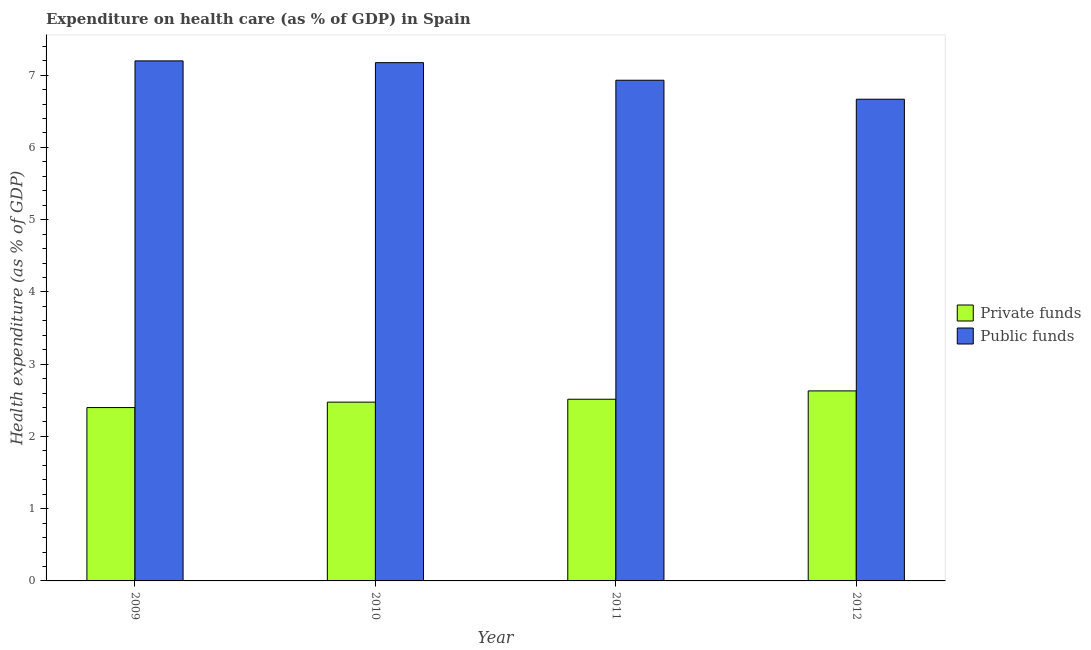Are the number of bars per tick equal to the number of legend labels?
Ensure brevity in your answer.  Yes. What is the label of the 2nd group of bars from the left?
Your answer should be very brief. 2010. In how many cases, is the number of bars for a given year not equal to the number of legend labels?
Your answer should be very brief. 0. What is the amount of private funds spent in healthcare in 2009?
Make the answer very short. 2.4. Across all years, what is the maximum amount of public funds spent in healthcare?
Your answer should be compact. 7.2. Across all years, what is the minimum amount of public funds spent in healthcare?
Your answer should be compact. 6.67. In which year was the amount of private funds spent in healthcare minimum?
Give a very brief answer. 2009. What is the total amount of public funds spent in healthcare in the graph?
Offer a very short reply. 27.97. What is the difference between the amount of public funds spent in healthcare in 2010 and that in 2011?
Offer a terse response. 0.24. What is the difference between the amount of public funds spent in healthcare in 2010 and the amount of private funds spent in healthcare in 2009?
Offer a terse response. -0.02. What is the average amount of public funds spent in healthcare per year?
Offer a very short reply. 6.99. In the year 2011, what is the difference between the amount of public funds spent in healthcare and amount of private funds spent in healthcare?
Provide a succinct answer. 0. What is the ratio of the amount of private funds spent in healthcare in 2009 to that in 2011?
Offer a very short reply. 0.95. Is the difference between the amount of private funds spent in healthcare in 2011 and 2012 greater than the difference between the amount of public funds spent in healthcare in 2011 and 2012?
Give a very brief answer. No. What is the difference between the highest and the second highest amount of public funds spent in healthcare?
Provide a short and direct response. 0.02. What is the difference between the highest and the lowest amount of public funds spent in healthcare?
Your response must be concise. 0.53. What does the 2nd bar from the left in 2011 represents?
Offer a very short reply. Public funds. What does the 2nd bar from the right in 2012 represents?
Offer a very short reply. Private funds. Are all the bars in the graph horizontal?
Offer a terse response. No. Does the graph contain grids?
Offer a terse response. No. Where does the legend appear in the graph?
Your response must be concise. Center right. How are the legend labels stacked?
Offer a very short reply. Vertical. What is the title of the graph?
Your answer should be compact. Expenditure on health care (as % of GDP) in Spain. Does "IMF concessional" appear as one of the legend labels in the graph?
Make the answer very short. No. What is the label or title of the X-axis?
Your answer should be very brief. Year. What is the label or title of the Y-axis?
Provide a succinct answer. Health expenditure (as % of GDP). What is the Health expenditure (as % of GDP) of Private funds in 2009?
Keep it short and to the point. 2.4. What is the Health expenditure (as % of GDP) of Public funds in 2009?
Provide a succinct answer. 7.2. What is the Health expenditure (as % of GDP) of Private funds in 2010?
Offer a very short reply. 2.47. What is the Health expenditure (as % of GDP) in Public funds in 2010?
Your answer should be very brief. 7.17. What is the Health expenditure (as % of GDP) in Private funds in 2011?
Keep it short and to the point. 2.51. What is the Health expenditure (as % of GDP) of Public funds in 2011?
Make the answer very short. 6.93. What is the Health expenditure (as % of GDP) of Private funds in 2012?
Give a very brief answer. 2.63. What is the Health expenditure (as % of GDP) of Public funds in 2012?
Provide a succinct answer. 6.67. Across all years, what is the maximum Health expenditure (as % of GDP) in Private funds?
Your answer should be compact. 2.63. Across all years, what is the maximum Health expenditure (as % of GDP) in Public funds?
Offer a very short reply. 7.2. Across all years, what is the minimum Health expenditure (as % of GDP) in Private funds?
Your response must be concise. 2.4. Across all years, what is the minimum Health expenditure (as % of GDP) of Public funds?
Ensure brevity in your answer.  6.67. What is the total Health expenditure (as % of GDP) of Private funds in the graph?
Your response must be concise. 10.02. What is the total Health expenditure (as % of GDP) of Public funds in the graph?
Your answer should be compact. 27.97. What is the difference between the Health expenditure (as % of GDP) in Private funds in 2009 and that in 2010?
Provide a short and direct response. -0.08. What is the difference between the Health expenditure (as % of GDP) in Public funds in 2009 and that in 2010?
Offer a terse response. 0.02. What is the difference between the Health expenditure (as % of GDP) in Private funds in 2009 and that in 2011?
Your answer should be compact. -0.12. What is the difference between the Health expenditure (as % of GDP) of Public funds in 2009 and that in 2011?
Provide a short and direct response. 0.27. What is the difference between the Health expenditure (as % of GDP) of Private funds in 2009 and that in 2012?
Your answer should be very brief. -0.23. What is the difference between the Health expenditure (as % of GDP) in Public funds in 2009 and that in 2012?
Provide a short and direct response. 0.53. What is the difference between the Health expenditure (as % of GDP) in Private funds in 2010 and that in 2011?
Ensure brevity in your answer.  -0.04. What is the difference between the Health expenditure (as % of GDP) of Public funds in 2010 and that in 2011?
Keep it short and to the point. 0.24. What is the difference between the Health expenditure (as % of GDP) of Private funds in 2010 and that in 2012?
Keep it short and to the point. -0.16. What is the difference between the Health expenditure (as % of GDP) in Public funds in 2010 and that in 2012?
Provide a succinct answer. 0.51. What is the difference between the Health expenditure (as % of GDP) in Private funds in 2011 and that in 2012?
Keep it short and to the point. -0.12. What is the difference between the Health expenditure (as % of GDP) in Public funds in 2011 and that in 2012?
Keep it short and to the point. 0.26. What is the difference between the Health expenditure (as % of GDP) in Private funds in 2009 and the Health expenditure (as % of GDP) in Public funds in 2010?
Your response must be concise. -4.77. What is the difference between the Health expenditure (as % of GDP) in Private funds in 2009 and the Health expenditure (as % of GDP) in Public funds in 2011?
Your answer should be compact. -4.53. What is the difference between the Health expenditure (as % of GDP) in Private funds in 2009 and the Health expenditure (as % of GDP) in Public funds in 2012?
Provide a succinct answer. -4.27. What is the difference between the Health expenditure (as % of GDP) in Private funds in 2010 and the Health expenditure (as % of GDP) in Public funds in 2011?
Give a very brief answer. -4.46. What is the difference between the Health expenditure (as % of GDP) of Private funds in 2010 and the Health expenditure (as % of GDP) of Public funds in 2012?
Give a very brief answer. -4.19. What is the difference between the Health expenditure (as % of GDP) in Private funds in 2011 and the Health expenditure (as % of GDP) in Public funds in 2012?
Your answer should be compact. -4.15. What is the average Health expenditure (as % of GDP) in Private funds per year?
Ensure brevity in your answer.  2.5. What is the average Health expenditure (as % of GDP) in Public funds per year?
Your answer should be very brief. 6.99. In the year 2009, what is the difference between the Health expenditure (as % of GDP) in Private funds and Health expenditure (as % of GDP) in Public funds?
Keep it short and to the point. -4.8. In the year 2010, what is the difference between the Health expenditure (as % of GDP) in Private funds and Health expenditure (as % of GDP) in Public funds?
Your answer should be compact. -4.7. In the year 2011, what is the difference between the Health expenditure (as % of GDP) in Private funds and Health expenditure (as % of GDP) in Public funds?
Offer a terse response. -4.42. In the year 2012, what is the difference between the Health expenditure (as % of GDP) in Private funds and Health expenditure (as % of GDP) in Public funds?
Give a very brief answer. -4.04. What is the ratio of the Health expenditure (as % of GDP) in Private funds in 2009 to that in 2010?
Provide a succinct answer. 0.97. What is the ratio of the Health expenditure (as % of GDP) in Public funds in 2009 to that in 2010?
Your answer should be very brief. 1. What is the ratio of the Health expenditure (as % of GDP) in Private funds in 2009 to that in 2011?
Offer a very short reply. 0.95. What is the ratio of the Health expenditure (as % of GDP) in Public funds in 2009 to that in 2011?
Give a very brief answer. 1.04. What is the ratio of the Health expenditure (as % of GDP) of Private funds in 2009 to that in 2012?
Your answer should be compact. 0.91. What is the ratio of the Health expenditure (as % of GDP) in Public funds in 2009 to that in 2012?
Make the answer very short. 1.08. What is the ratio of the Health expenditure (as % of GDP) of Private funds in 2010 to that in 2011?
Provide a short and direct response. 0.98. What is the ratio of the Health expenditure (as % of GDP) of Public funds in 2010 to that in 2011?
Provide a short and direct response. 1.04. What is the ratio of the Health expenditure (as % of GDP) in Private funds in 2010 to that in 2012?
Your response must be concise. 0.94. What is the ratio of the Health expenditure (as % of GDP) of Public funds in 2010 to that in 2012?
Keep it short and to the point. 1.08. What is the ratio of the Health expenditure (as % of GDP) in Private funds in 2011 to that in 2012?
Make the answer very short. 0.96. What is the ratio of the Health expenditure (as % of GDP) of Public funds in 2011 to that in 2012?
Keep it short and to the point. 1.04. What is the difference between the highest and the second highest Health expenditure (as % of GDP) of Private funds?
Offer a very short reply. 0.12. What is the difference between the highest and the second highest Health expenditure (as % of GDP) of Public funds?
Your answer should be compact. 0.02. What is the difference between the highest and the lowest Health expenditure (as % of GDP) in Private funds?
Provide a short and direct response. 0.23. What is the difference between the highest and the lowest Health expenditure (as % of GDP) of Public funds?
Make the answer very short. 0.53. 